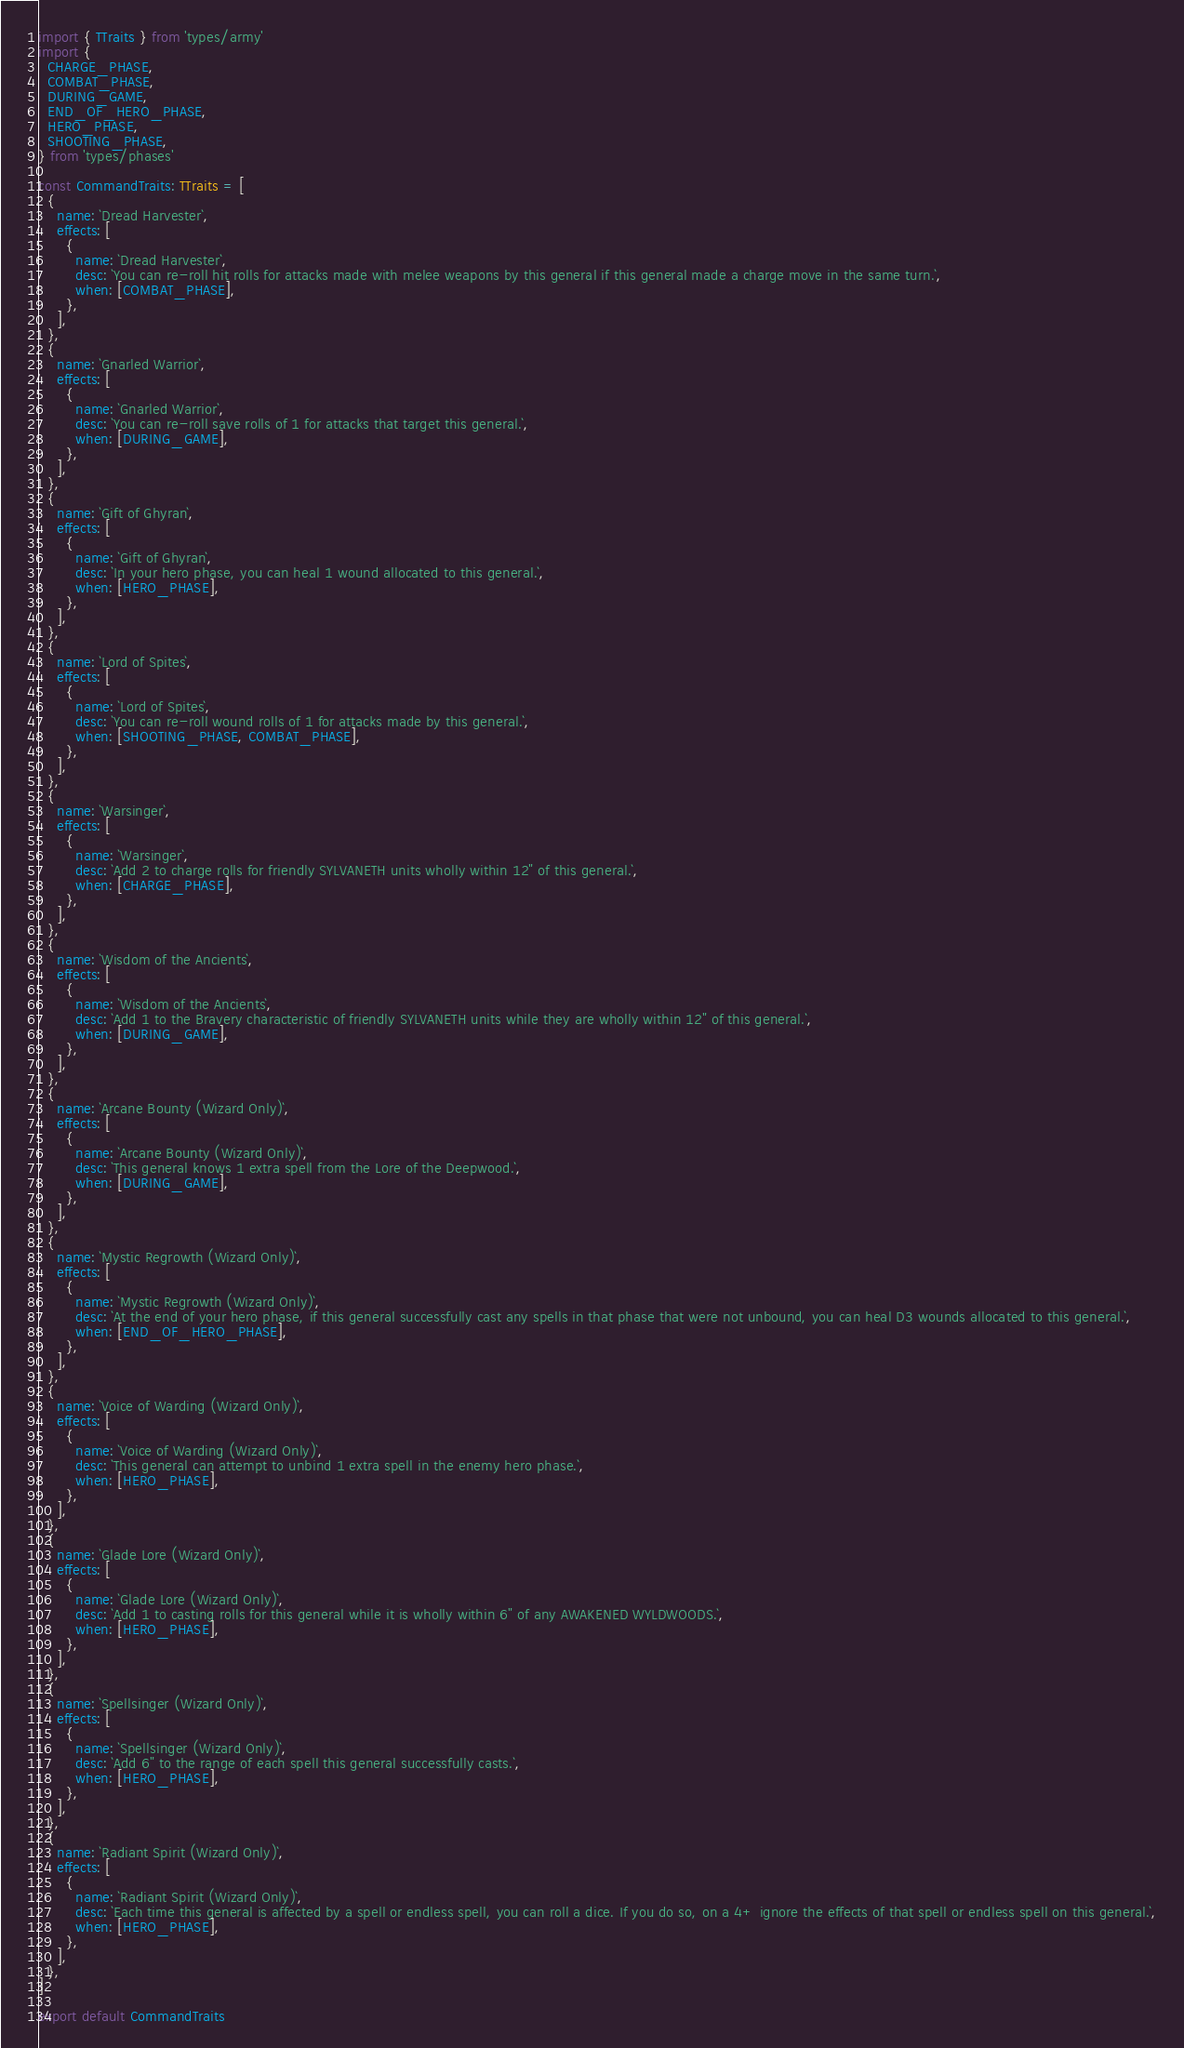<code> <loc_0><loc_0><loc_500><loc_500><_TypeScript_>import { TTraits } from 'types/army'
import {
  CHARGE_PHASE,
  COMBAT_PHASE,
  DURING_GAME,
  END_OF_HERO_PHASE,
  HERO_PHASE,
  SHOOTING_PHASE,
} from 'types/phases'

const CommandTraits: TTraits = [
  {
    name: `Dread Harvester`,
    effects: [
      {
        name: `Dread Harvester`,
        desc: `You can re-roll hit rolls for attacks made with melee weapons by this general if this general made a charge move in the same turn.`,
        when: [COMBAT_PHASE],
      },
    ],
  },
  {
    name: `Gnarled Warrior`,
    effects: [
      {
        name: `Gnarled Warrior`,
        desc: `You can re-roll save rolls of 1 for attacks that target this general.`,
        when: [DURING_GAME],
      },
    ],
  },
  {
    name: `Gift of Ghyran`,
    effects: [
      {
        name: `Gift of Ghyran`,
        desc: `In your hero phase, you can heal 1 wound allocated to this general.`,
        when: [HERO_PHASE],
      },
    ],
  },
  {
    name: `Lord of Spites`,
    effects: [
      {
        name: `Lord of Spites`,
        desc: `You can re-roll wound rolls of 1 for attacks made by this general.`,
        when: [SHOOTING_PHASE, COMBAT_PHASE],
      },
    ],
  },
  {
    name: `Warsinger`,
    effects: [
      {
        name: `Warsinger`,
        desc: `Add 2 to charge rolls for friendly SYLVANETH units wholly within 12" of this general.`,
        when: [CHARGE_PHASE],
      },
    ],
  },
  {
    name: `Wisdom of the Ancients`,
    effects: [
      {
        name: `Wisdom of the Ancients`,
        desc: `Add 1 to the Bravery characteristic of friendly SYLVANETH units while they are wholly within 12" of this general.`,
        when: [DURING_GAME],
      },
    ],
  },
  {
    name: `Arcane Bounty (Wizard Only)`,
    effects: [
      {
        name: `Arcane Bounty (Wizard Only)`,
        desc: `This general knows 1 extra spell from the Lore of the Deepwood.`,
        when: [DURING_GAME],
      },
    ],
  },
  {
    name: `Mystic Regrowth (Wizard Only)`,
    effects: [
      {
        name: `Mystic Regrowth (Wizard Only)`,
        desc: `At the end of your hero phase, if this general successfully cast any spells in that phase that were not unbound, you can heal D3 wounds allocated to this general.`,
        when: [END_OF_HERO_PHASE],
      },
    ],
  },
  {
    name: `Voice of Warding (Wizard Only)`,
    effects: [
      {
        name: `Voice of Warding (Wizard Only)`,
        desc: `This general can attempt to unbind 1 extra spell in the enemy hero phase.`,
        when: [HERO_PHASE],
      },
    ],
  },
  {
    name: `Glade Lore (Wizard Only)`,
    effects: [
      {
        name: `Glade Lore (Wizard Only)`,
        desc: `Add 1 to casting rolls for this general while it is wholly within 6" of any AWAKENED WYLDWOODS.`,
        when: [HERO_PHASE],
      },
    ],
  },
  {
    name: `Spellsinger (Wizard Only)`,
    effects: [
      {
        name: `Spellsinger (Wizard Only)`,
        desc: `Add 6" to the range of each spell this general successfully casts.`,
        when: [HERO_PHASE],
      },
    ],
  },
  {
    name: `Radiant Spirit (Wizard Only)`,
    effects: [
      {
        name: `Radiant Spirit (Wizard Only)`,
        desc: `Each time this general is affected by a spell or endless spell, you can roll a dice. If you do so, on a 4+ ignore the effects of that spell or endless spell on this general.`,
        when: [HERO_PHASE],
      },
    ],
  },
]

export default CommandTraits
</code> 